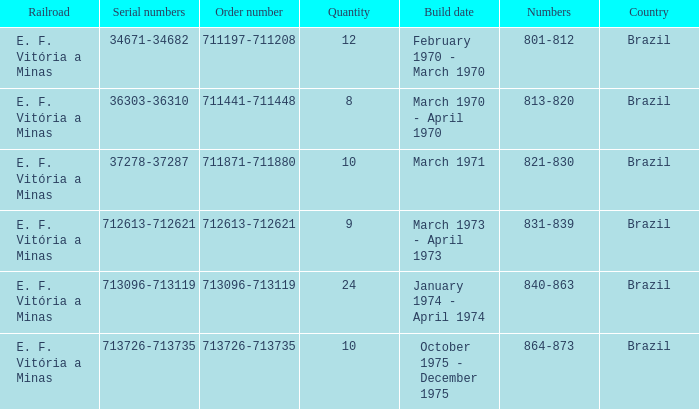What country has the order number 711871-711880? Brazil. Can you parse all the data within this table? {'header': ['Railroad', 'Serial numbers', 'Order number', 'Quantity', 'Build date', 'Numbers', 'Country'], 'rows': [['E. F. Vitória a Minas', '34671-34682', '711197-711208', '12', 'February 1970 - March 1970', '801-812', 'Brazil'], ['E. F. Vitória a Minas', '36303-36310', '711441-711448', '8', 'March 1970 - April 1970', '813-820', 'Brazil'], ['E. F. Vitória a Minas', '37278-37287', '711871-711880', '10', 'March 1971', '821-830', 'Brazil'], ['E. F. Vitória a Minas', '712613-712621', '712613-712621', '9', 'March 1973 - April 1973', '831-839', 'Brazil'], ['E. F. Vitória a Minas', '713096-713119', '713096-713119', '24', 'January 1974 - April 1974', '840-863', 'Brazil'], ['E. F. Vitória a Minas', '713726-713735', '713726-713735', '10', 'October 1975 - December 1975', '864-873', 'Brazil']]} 